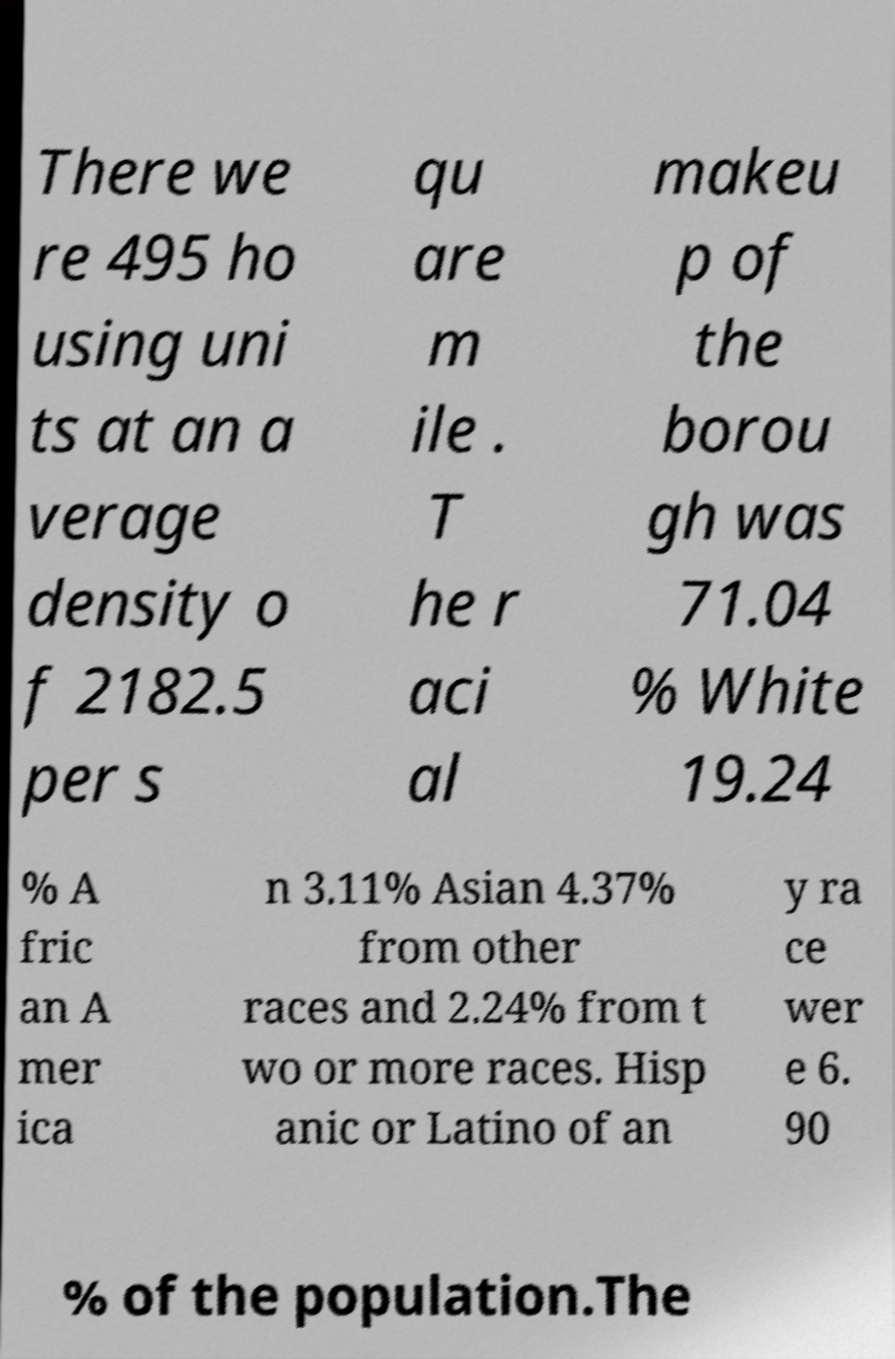Could you extract and type out the text from this image? There we re 495 ho using uni ts at an a verage density o f 2182.5 per s qu are m ile . T he r aci al makeu p of the borou gh was 71.04 % White 19.24 % A fric an A mer ica n 3.11% Asian 4.37% from other races and 2.24% from t wo or more races. Hisp anic or Latino of an y ra ce wer e 6. 90 % of the population.The 